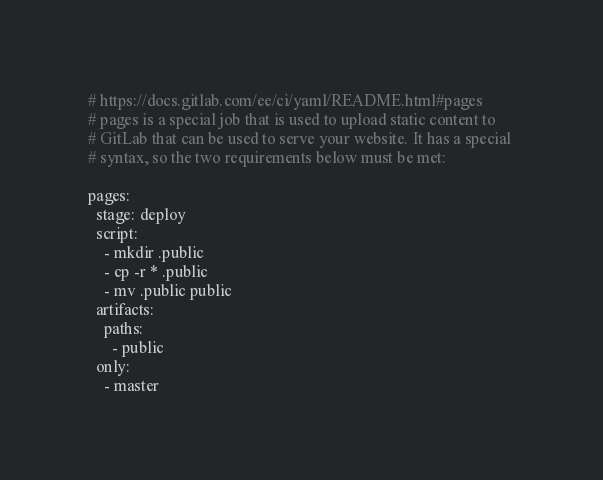<code> <loc_0><loc_0><loc_500><loc_500><_YAML_># https://docs.gitlab.com/ee/ci/yaml/README.html#pages
# pages is a special job that is used to upload static content to 
# GitLab that can be used to serve your website. It has a special 
# syntax, so the two requirements below must be met:

pages:
  stage: deploy
  script:
    - mkdir .public
    - cp -r * .public
    - mv .public public
  artifacts:
    paths:
      - public
  only:
    - master
</code> 